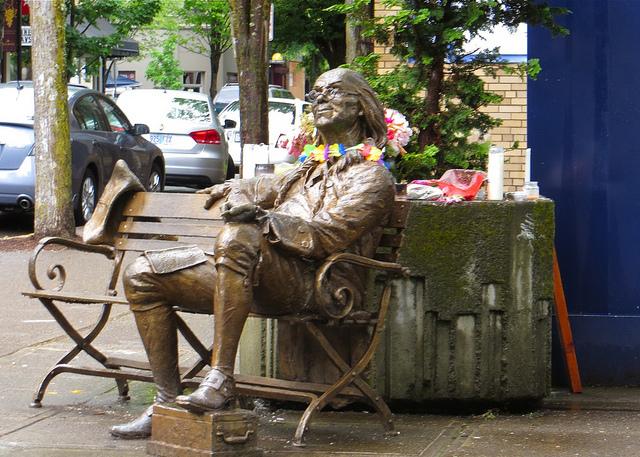What material is the building in the background made of?
Quick response, please. Brick. What is the statue wearing around its neck?
Concise answer only. Lei. Who is sitting on a bench?
Short answer required. Statue. 